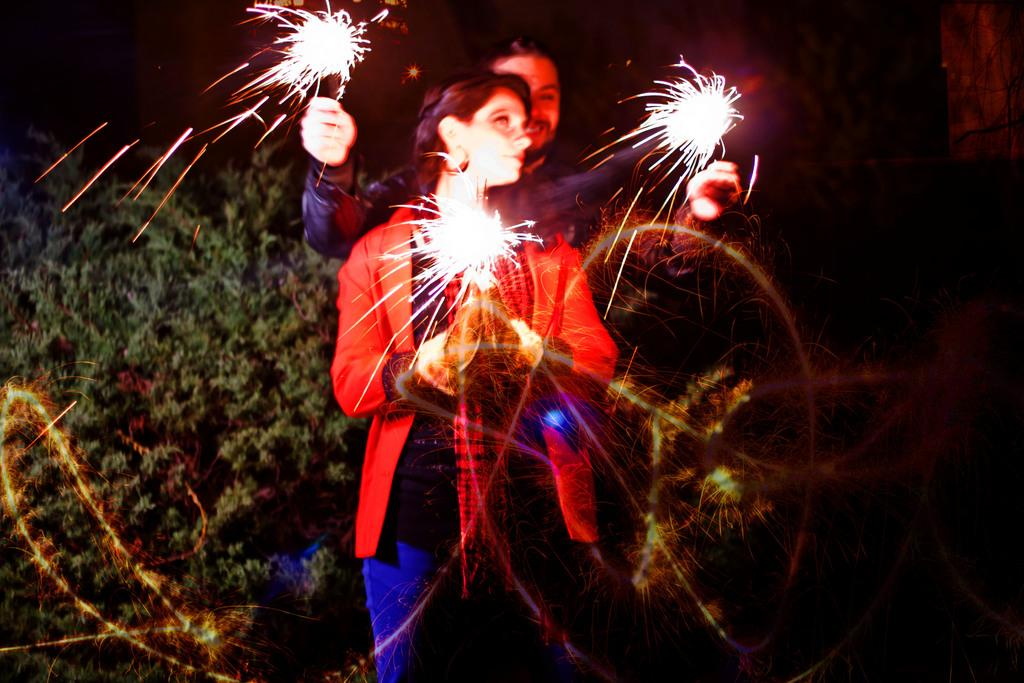How many people are in the image? There are two persons standing in the image. What are the persons holding in their hands? The persons are holding objects that look like crackers. What type of natural vegetation can be seen in the image? There are trees in the image. What is the color of the background in the image? The background of the image is dark. Can you tell me what type of brush is being used by the person on the left in the image? There is no brush present in the image; the persons are holding objects that look like crackers. 